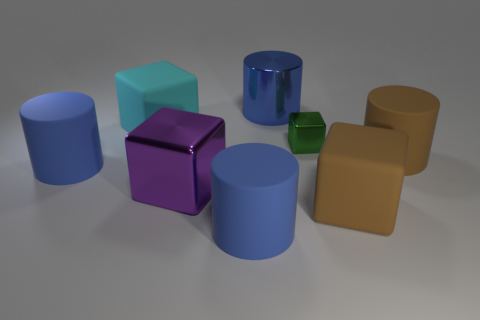If I wanted to arrange the cubes in order of size, how should I place them? To arrange the cubes in order of size from smallest to largest, you'd begin with the tiny green cube, followed by the purple cube, and finally the light teal cube which is the largest of the three. 